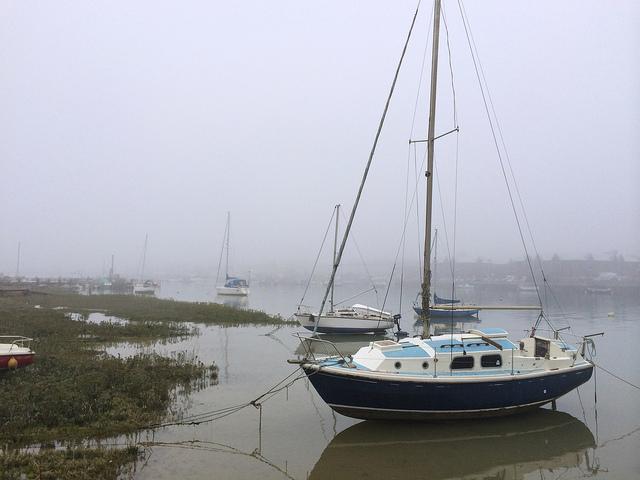How many ship masts are there?
Give a very brief answer. 6. 